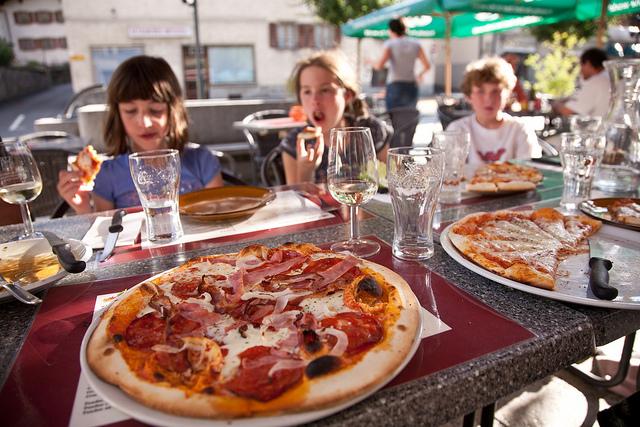Is everyone eating the same thing?
Write a very short answer. Yes. What cola brand is on the glasses?
Short answer required. Coca cola. How many slices are on the closest plate?
Short answer required. 8. Are these people drinking beer?
Short answer required. No. What type of pork is on the pizza?
Write a very short answer. Bacon. What food is this?
Write a very short answer. Pizza. 